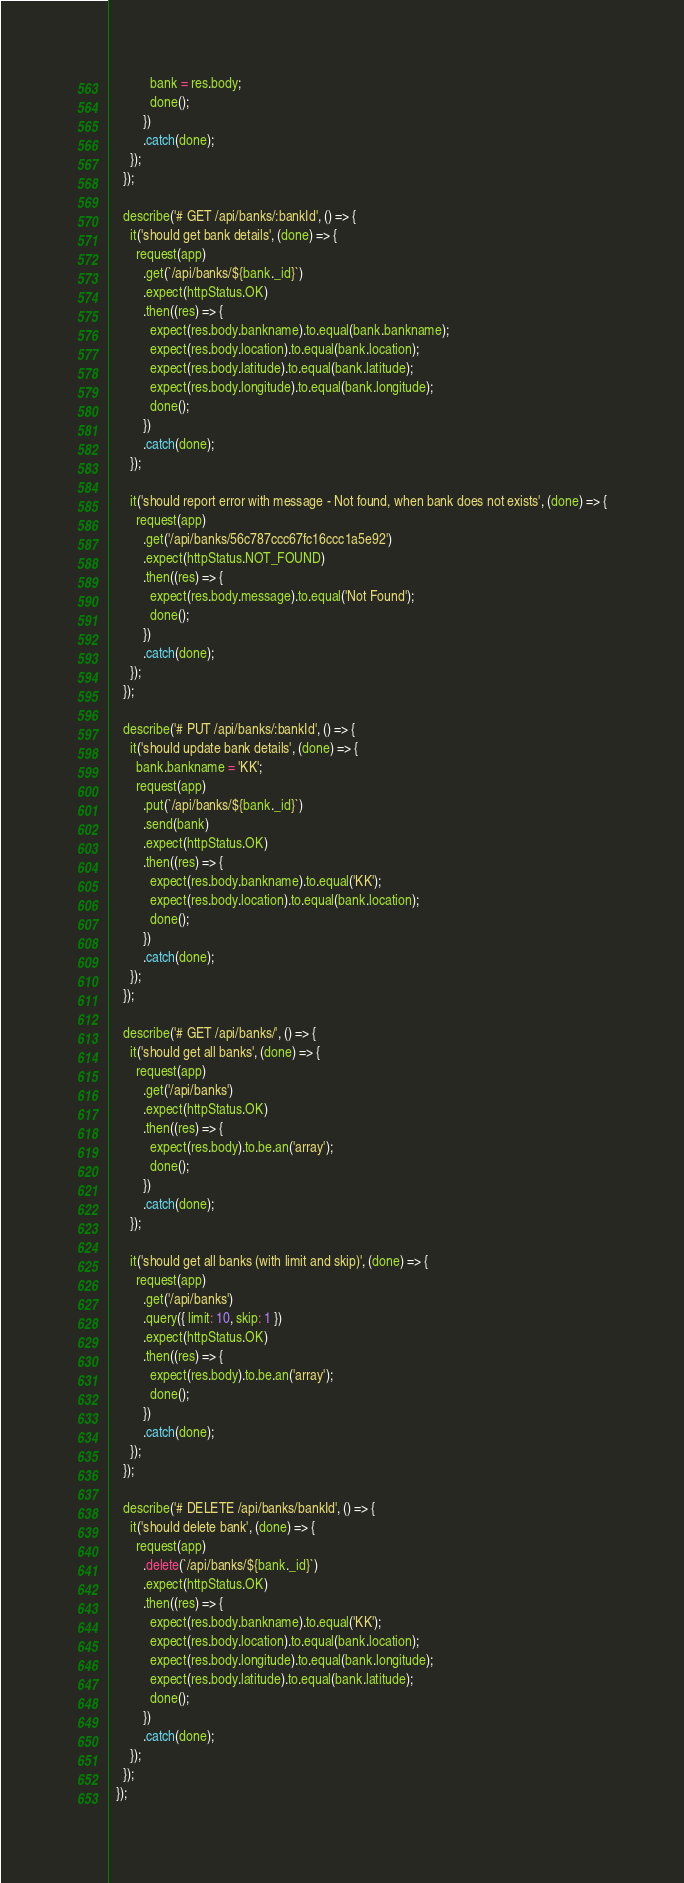Convert code to text. <code><loc_0><loc_0><loc_500><loc_500><_JavaScript_>            bank = res.body;
            done();
          })
          .catch(done);
      });
    });

    describe('# GET /api/banks/:bankId', () => {
      it('should get bank details', (done) => {
        request(app)
          .get(`/api/banks/${bank._id}`)
          .expect(httpStatus.OK)
          .then((res) => {
            expect(res.body.bankname).to.equal(bank.bankname);
            expect(res.body.location).to.equal(bank.location);
            expect(res.body.latitude).to.equal(bank.latitude);
            expect(res.body.longitude).to.equal(bank.longitude);
            done();
          })
          .catch(done);
      });

      it('should report error with message - Not found, when bank does not exists', (done) => {
        request(app)
          .get('/api/banks/56c787ccc67fc16ccc1a5e92')
          .expect(httpStatus.NOT_FOUND)
          .then((res) => {
            expect(res.body.message).to.equal('Not Found');
            done();
          })
          .catch(done);
      });
    });

    describe('# PUT /api/banks/:bankId', () => {
      it('should update bank details', (done) => {
        bank.bankname = 'KK';
        request(app)
          .put(`/api/banks/${bank._id}`)
          .send(bank)
          .expect(httpStatus.OK)
          .then((res) => {
            expect(res.body.bankname).to.equal('KK');
            expect(res.body.location).to.equal(bank.location);
            done();
          })
          .catch(done);
      });
    });

    describe('# GET /api/banks/', () => {
      it('should get all banks', (done) => {
        request(app)
          .get('/api/banks')
          .expect(httpStatus.OK)
          .then((res) => {
            expect(res.body).to.be.an('array');
            done();
          })
          .catch(done);
      });

      it('should get all banks (with limit and skip)', (done) => {
        request(app)
          .get('/api/banks')
          .query({ limit: 10, skip: 1 })
          .expect(httpStatus.OK)
          .then((res) => {
            expect(res.body).to.be.an('array');
            done();
          })
          .catch(done);
      });
    });

    describe('# DELETE /api/banks/bankId', () => {
      it('should delete bank', (done) => {
        request(app)
          .delete(`/api/banks/${bank._id}`)
          .expect(httpStatus.OK)
          .then((res) => {
            expect(res.body.bankname).to.equal('KK');
            expect(res.body.location).to.equal(bank.location);
            expect(res.body.longitude).to.equal(bank.longitude);
            expect(res.body.latitude).to.equal(bank.latitude);
            done();
          })
          .catch(done);
      });
    });
  });
</code> 